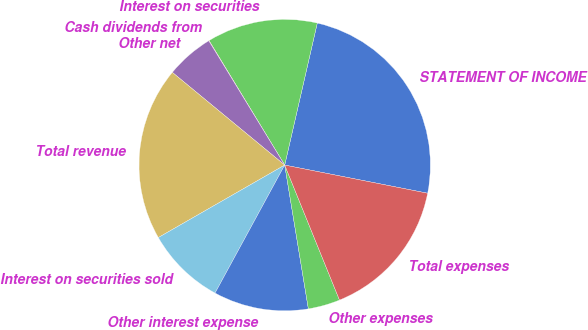<chart> <loc_0><loc_0><loc_500><loc_500><pie_chart><fcel>STATEMENT OF INCOME<fcel>Interest on securities<fcel>Cash dividends from<fcel>Other net<fcel>Total revenue<fcel>Interest on securities sold<fcel>Other interest expense<fcel>Other expenses<fcel>Total expenses<nl><fcel>24.51%<fcel>12.28%<fcel>0.04%<fcel>5.29%<fcel>19.27%<fcel>8.78%<fcel>10.53%<fcel>3.54%<fcel>15.77%<nl></chart> 